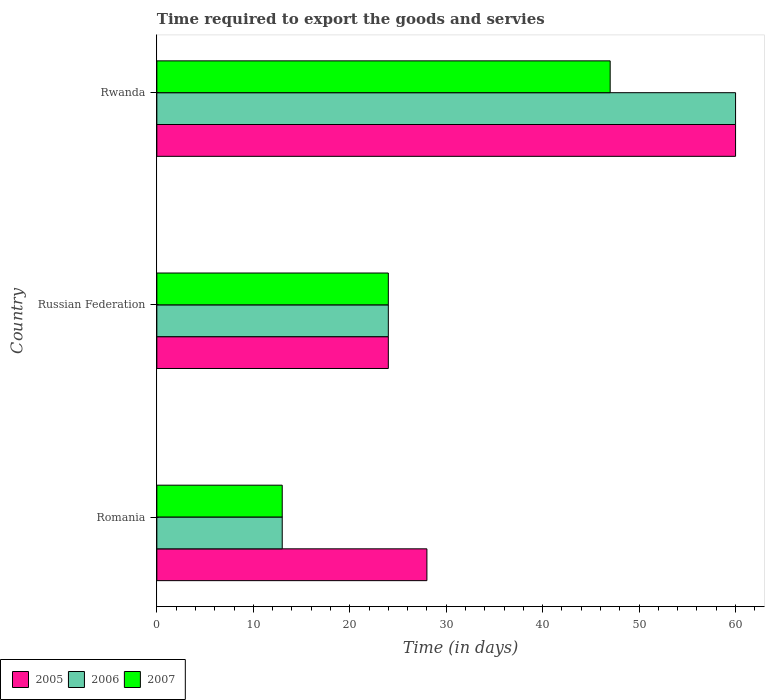How many different coloured bars are there?
Give a very brief answer. 3. What is the label of the 3rd group of bars from the top?
Make the answer very short. Romania. In how many cases, is the number of bars for a given country not equal to the number of legend labels?
Your answer should be very brief. 0. What is the number of days required to export the goods and services in 2007 in Romania?
Give a very brief answer. 13. In which country was the number of days required to export the goods and services in 2005 maximum?
Provide a short and direct response. Rwanda. In which country was the number of days required to export the goods and services in 2007 minimum?
Offer a very short reply. Romania. What is the total number of days required to export the goods and services in 2006 in the graph?
Give a very brief answer. 97. What is the difference between the number of days required to export the goods and services in 2006 in Romania and that in Rwanda?
Your response must be concise. -47. What is the difference between the number of days required to export the goods and services in 2005 in Romania and the number of days required to export the goods and services in 2006 in Rwanda?
Provide a succinct answer. -32. What is the average number of days required to export the goods and services in 2005 per country?
Provide a short and direct response. 37.33. What is the difference between the number of days required to export the goods and services in 2005 and number of days required to export the goods and services in 2007 in Russian Federation?
Provide a succinct answer. 0. In how many countries, is the number of days required to export the goods and services in 2005 greater than 38 days?
Ensure brevity in your answer.  1. What is the ratio of the number of days required to export the goods and services in 2006 in Romania to that in Russian Federation?
Provide a succinct answer. 0.54. Is the difference between the number of days required to export the goods and services in 2005 in Romania and Russian Federation greater than the difference between the number of days required to export the goods and services in 2007 in Romania and Russian Federation?
Offer a very short reply. Yes. What is the difference between the highest and the second highest number of days required to export the goods and services in 2005?
Your answer should be very brief. 32. What is the difference between the highest and the lowest number of days required to export the goods and services in 2006?
Make the answer very short. 47. Is the sum of the number of days required to export the goods and services in 2006 in Romania and Russian Federation greater than the maximum number of days required to export the goods and services in 2005 across all countries?
Keep it short and to the point. No. What does the 1st bar from the top in Russian Federation represents?
Offer a very short reply. 2007. Are all the bars in the graph horizontal?
Ensure brevity in your answer.  Yes. How many countries are there in the graph?
Provide a succinct answer. 3. What is the difference between two consecutive major ticks on the X-axis?
Your response must be concise. 10. Does the graph contain any zero values?
Your answer should be very brief. No. How many legend labels are there?
Provide a succinct answer. 3. How are the legend labels stacked?
Ensure brevity in your answer.  Horizontal. What is the title of the graph?
Make the answer very short. Time required to export the goods and servies. Does "2007" appear as one of the legend labels in the graph?
Give a very brief answer. Yes. What is the label or title of the X-axis?
Provide a succinct answer. Time (in days). What is the Time (in days) in 2005 in Romania?
Give a very brief answer. 28. What is the Time (in days) of 2007 in Russian Federation?
Provide a short and direct response. 24. What is the Time (in days) of 2005 in Rwanda?
Your answer should be compact. 60. What is the Time (in days) in 2006 in Rwanda?
Give a very brief answer. 60. What is the Time (in days) in 2007 in Rwanda?
Provide a short and direct response. 47. Across all countries, what is the maximum Time (in days) in 2005?
Make the answer very short. 60. Across all countries, what is the minimum Time (in days) of 2006?
Offer a terse response. 13. Across all countries, what is the minimum Time (in days) in 2007?
Your answer should be very brief. 13. What is the total Time (in days) of 2005 in the graph?
Keep it short and to the point. 112. What is the total Time (in days) of 2006 in the graph?
Offer a very short reply. 97. What is the total Time (in days) in 2007 in the graph?
Provide a short and direct response. 84. What is the difference between the Time (in days) of 2005 in Romania and that in Russian Federation?
Give a very brief answer. 4. What is the difference between the Time (in days) of 2006 in Romania and that in Russian Federation?
Your response must be concise. -11. What is the difference between the Time (in days) in 2007 in Romania and that in Russian Federation?
Provide a succinct answer. -11. What is the difference between the Time (in days) of 2005 in Romania and that in Rwanda?
Your response must be concise. -32. What is the difference between the Time (in days) in 2006 in Romania and that in Rwanda?
Give a very brief answer. -47. What is the difference between the Time (in days) of 2007 in Romania and that in Rwanda?
Provide a succinct answer. -34. What is the difference between the Time (in days) of 2005 in Russian Federation and that in Rwanda?
Provide a short and direct response. -36. What is the difference between the Time (in days) of 2006 in Russian Federation and that in Rwanda?
Make the answer very short. -36. What is the difference between the Time (in days) in 2005 in Romania and the Time (in days) in 2006 in Russian Federation?
Ensure brevity in your answer.  4. What is the difference between the Time (in days) in 2005 in Romania and the Time (in days) in 2007 in Russian Federation?
Make the answer very short. 4. What is the difference between the Time (in days) of 2005 in Romania and the Time (in days) of 2006 in Rwanda?
Provide a short and direct response. -32. What is the difference between the Time (in days) in 2006 in Romania and the Time (in days) in 2007 in Rwanda?
Ensure brevity in your answer.  -34. What is the difference between the Time (in days) in 2005 in Russian Federation and the Time (in days) in 2006 in Rwanda?
Keep it short and to the point. -36. What is the difference between the Time (in days) of 2006 in Russian Federation and the Time (in days) of 2007 in Rwanda?
Make the answer very short. -23. What is the average Time (in days) of 2005 per country?
Your answer should be very brief. 37.33. What is the average Time (in days) in 2006 per country?
Your response must be concise. 32.33. What is the average Time (in days) in 2007 per country?
Provide a short and direct response. 28. What is the difference between the Time (in days) of 2005 and Time (in days) of 2007 in Romania?
Keep it short and to the point. 15. What is the difference between the Time (in days) of 2005 and Time (in days) of 2006 in Rwanda?
Your answer should be compact. 0. What is the difference between the Time (in days) in 2005 and Time (in days) in 2007 in Rwanda?
Provide a succinct answer. 13. What is the difference between the Time (in days) in 2006 and Time (in days) in 2007 in Rwanda?
Ensure brevity in your answer.  13. What is the ratio of the Time (in days) in 2005 in Romania to that in Russian Federation?
Provide a short and direct response. 1.17. What is the ratio of the Time (in days) of 2006 in Romania to that in Russian Federation?
Keep it short and to the point. 0.54. What is the ratio of the Time (in days) in 2007 in Romania to that in Russian Federation?
Offer a very short reply. 0.54. What is the ratio of the Time (in days) of 2005 in Romania to that in Rwanda?
Provide a succinct answer. 0.47. What is the ratio of the Time (in days) in 2006 in Romania to that in Rwanda?
Offer a terse response. 0.22. What is the ratio of the Time (in days) of 2007 in Romania to that in Rwanda?
Your answer should be very brief. 0.28. What is the ratio of the Time (in days) in 2007 in Russian Federation to that in Rwanda?
Your response must be concise. 0.51. What is the difference between the highest and the second highest Time (in days) of 2006?
Your response must be concise. 36. What is the difference between the highest and the second highest Time (in days) of 2007?
Your answer should be compact. 23. What is the difference between the highest and the lowest Time (in days) of 2005?
Offer a terse response. 36. What is the difference between the highest and the lowest Time (in days) in 2006?
Your answer should be very brief. 47. 